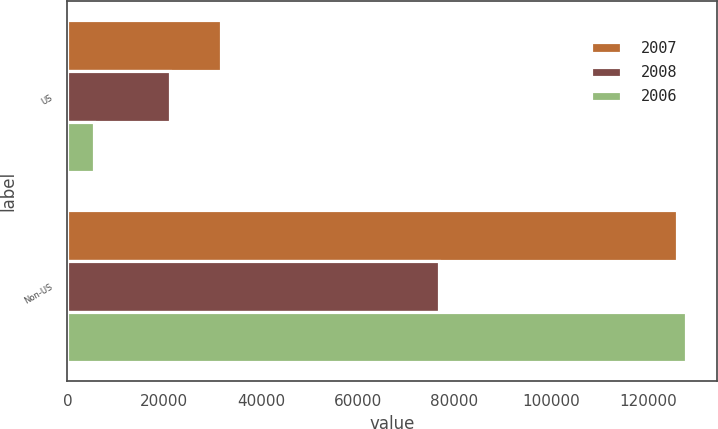Convert chart to OTSL. <chart><loc_0><loc_0><loc_500><loc_500><stacked_bar_chart><ecel><fcel>US<fcel>Non-US<nl><fcel>2007<fcel>31783<fcel>126072<nl><fcel>2008<fcel>21219<fcel>76754<nl><fcel>2006<fcel>5472<fcel>127922<nl></chart> 